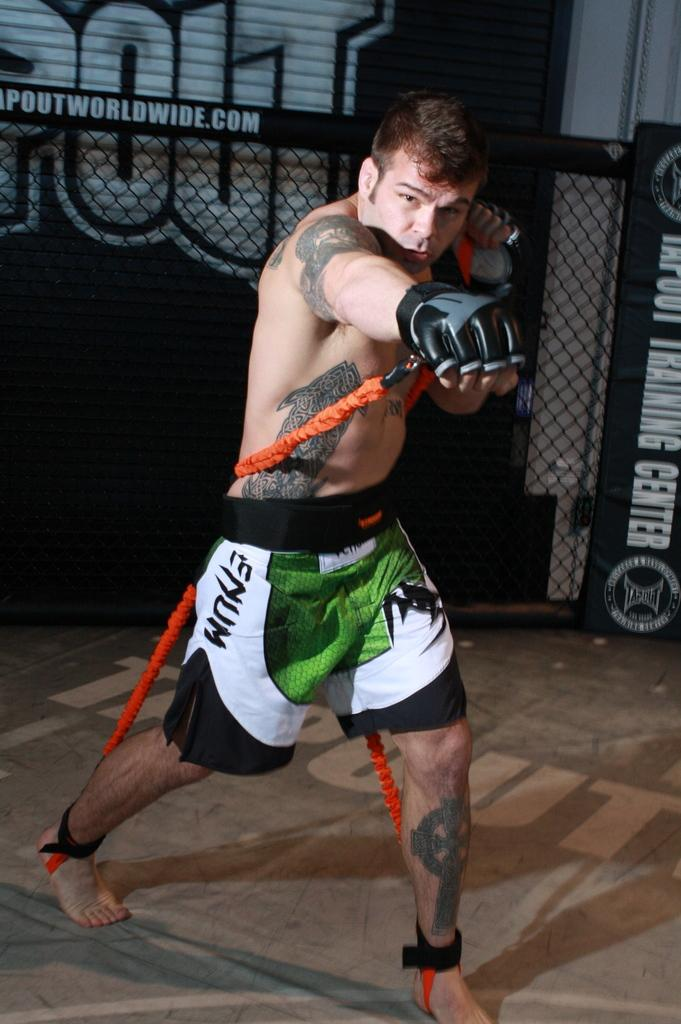What is the main subject of the image? There is a person in the image. What type of clothing is the person wearing? The person is wearing shorts and gloves. What is the person holding in his hands? The person is holding a rope in his hands. What is the person's posture in the image? The person is standing. What can be seen in the background of the image? There is fencing and a shutter in the background of the image. How does the land increase in the image? There is no reference to land or its increase in the image; it features a person holding a rope and wearing gloves and shorts. Is there a horse present in the image? No, there is no horse present in the image. 